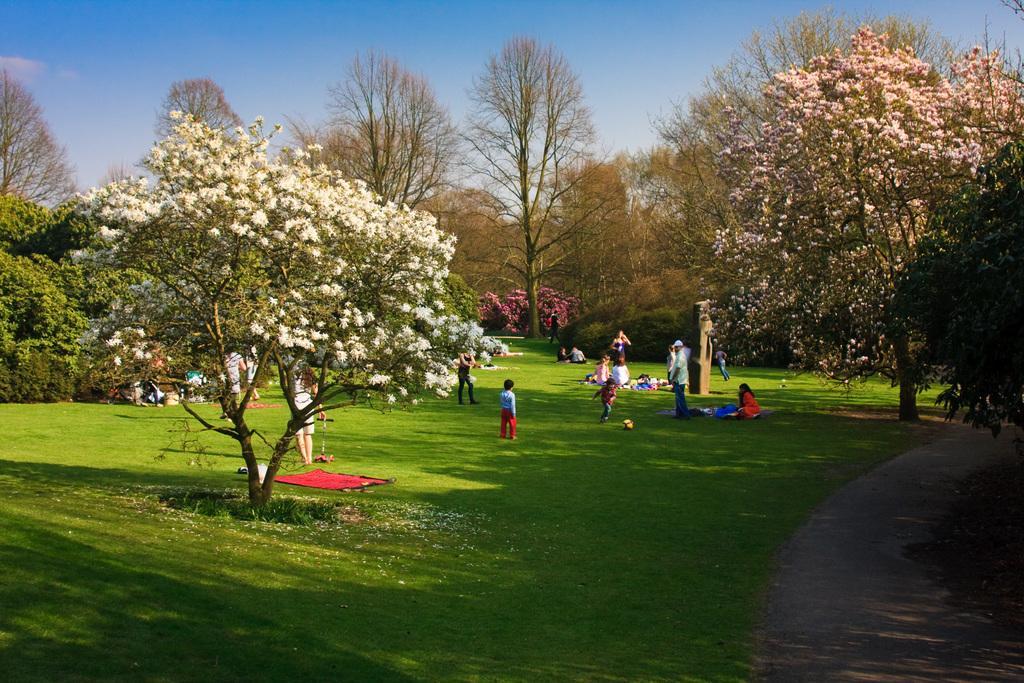Please provide a concise description of this image. In this picture we can see some people, clothes, some objects on the grass, path, trees and in the background we can see the sky. 